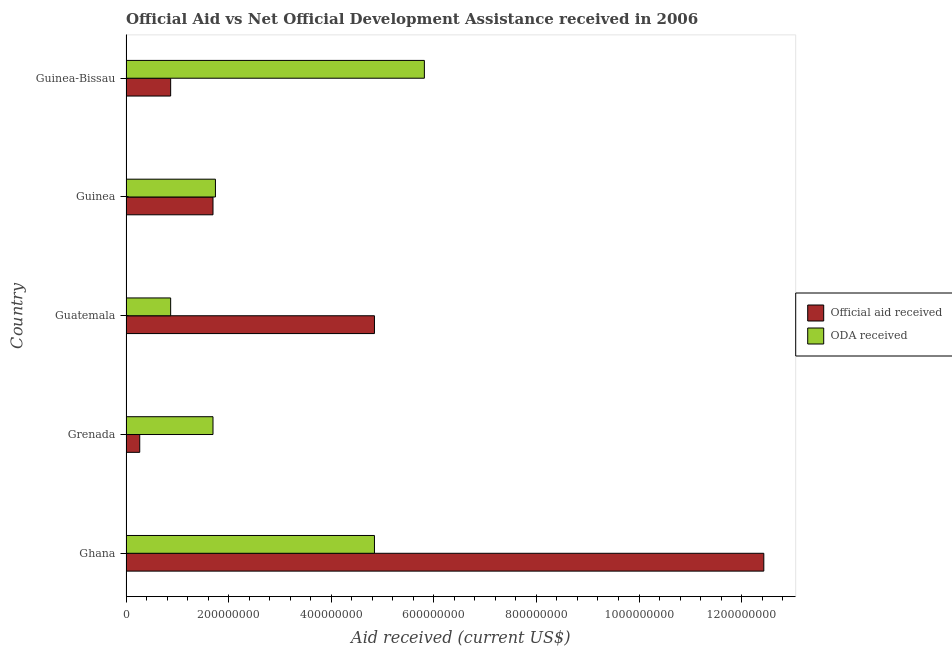Are the number of bars on each tick of the Y-axis equal?
Keep it short and to the point. Yes. How many bars are there on the 2nd tick from the top?
Offer a very short reply. 2. How many bars are there on the 4th tick from the bottom?
Provide a succinct answer. 2. What is the label of the 1st group of bars from the top?
Keep it short and to the point. Guinea-Bissau. What is the oda received in Guinea-Bissau?
Provide a succinct answer. 5.82e+08. Across all countries, what is the maximum official aid received?
Your answer should be very brief. 1.24e+09. Across all countries, what is the minimum official aid received?
Your answer should be very brief. 2.67e+07. In which country was the oda received maximum?
Your answer should be very brief. Guinea-Bissau. In which country was the official aid received minimum?
Provide a short and direct response. Grenada. What is the total oda received in the graph?
Provide a succinct answer. 1.50e+09. What is the difference between the oda received in Ghana and that in Guinea-Bissau?
Make the answer very short. -9.73e+07. What is the average oda received per country?
Your answer should be very brief. 2.99e+08. What is the difference between the oda received and official aid received in Grenada?
Your answer should be compact. 1.43e+08. Is the official aid received in Ghana less than that in Guatemala?
Provide a succinct answer. No. Is the difference between the official aid received in Grenada and Guinea greater than the difference between the oda received in Grenada and Guinea?
Your answer should be very brief. No. What is the difference between the highest and the second highest official aid received?
Offer a terse response. 7.59e+08. What is the difference between the highest and the lowest oda received?
Ensure brevity in your answer.  4.95e+08. Is the sum of the official aid received in Guatemala and Guinea greater than the maximum oda received across all countries?
Keep it short and to the point. Yes. What does the 1st bar from the top in Ghana represents?
Provide a short and direct response. ODA received. What does the 2nd bar from the bottom in Grenada represents?
Provide a succinct answer. ODA received. Are the values on the major ticks of X-axis written in scientific E-notation?
Offer a terse response. No. How many legend labels are there?
Make the answer very short. 2. What is the title of the graph?
Offer a very short reply. Official Aid vs Net Official Development Assistance received in 2006 . What is the label or title of the X-axis?
Provide a succinct answer. Aid received (current US$). What is the label or title of the Y-axis?
Offer a very short reply. Country. What is the Aid received (current US$) in Official aid received in Ghana?
Make the answer very short. 1.24e+09. What is the Aid received (current US$) of ODA received in Ghana?
Provide a succinct answer. 4.84e+08. What is the Aid received (current US$) in Official aid received in Grenada?
Give a very brief answer. 2.67e+07. What is the Aid received (current US$) of ODA received in Grenada?
Offer a very short reply. 1.70e+08. What is the Aid received (current US$) of Official aid received in Guatemala?
Make the answer very short. 4.84e+08. What is the Aid received (current US$) of ODA received in Guatemala?
Keep it short and to the point. 8.70e+07. What is the Aid received (current US$) in Official aid received in Guinea?
Your response must be concise. 1.70e+08. What is the Aid received (current US$) of ODA received in Guinea?
Your answer should be very brief. 1.74e+08. What is the Aid received (current US$) in Official aid received in Guinea-Bissau?
Give a very brief answer. 8.70e+07. What is the Aid received (current US$) in ODA received in Guinea-Bissau?
Your answer should be compact. 5.82e+08. Across all countries, what is the maximum Aid received (current US$) of Official aid received?
Keep it short and to the point. 1.24e+09. Across all countries, what is the maximum Aid received (current US$) of ODA received?
Offer a terse response. 5.82e+08. Across all countries, what is the minimum Aid received (current US$) in Official aid received?
Provide a succinct answer. 2.67e+07. Across all countries, what is the minimum Aid received (current US$) of ODA received?
Your answer should be very brief. 8.70e+07. What is the total Aid received (current US$) of Official aid received in the graph?
Ensure brevity in your answer.  2.01e+09. What is the total Aid received (current US$) in ODA received in the graph?
Make the answer very short. 1.50e+09. What is the difference between the Aid received (current US$) of Official aid received in Ghana and that in Grenada?
Your response must be concise. 1.22e+09. What is the difference between the Aid received (current US$) in ODA received in Ghana and that in Grenada?
Your answer should be very brief. 3.15e+08. What is the difference between the Aid received (current US$) in Official aid received in Ghana and that in Guatemala?
Offer a terse response. 7.59e+08. What is the difference between the Aid received (current US$) in ODA received in Ghana and that in Guatemala?
Ensure brevity in your answer.  3.97e+08. What is the difference between the Aid received (current US$) of Official aid received in Ghana and that in Guinea?
Ensure brevity in your answer.  1.07e+09. What is the difference between the Aid received (current US$) of ODA received in Ghana and that in Guinea?
Your response must be concise. 3.10e+08. What is the difference between the Aid received (current US$) of Official aid received in Ghana and that in Guinea-Bissau?
Offer a very short reply. 1.16e+09. What is the difference between the Aid received (current US$) in ODA received in Ghana and that in Guinea-Bissau?
Keep it short and to the point. -9.73e+07. What is the difference between the Aid received (current US$) of Official aid received in Grenada and that in Guatemala?
Give a very brief answer. -4.58e+08. What is the difference between the Aid received (current US$) of ODA received in Grenada and that in Guatemala?
Ensure brevity in your answer.  8.25e+07. What is the difference between the Aid received (current US$) of Official aid received in Grenada and that in Guinea?
Your answer should be very brief. -1.43e+08. What is the difference between the Aid received (current US$) of ODA received in Grenada and that in Guinea?
Ensure brevity in your answer.  -4.76e+06. What is the difference between the Aid received (current US$) in Official aid received in Grenada and that in Guinea-Bissau?
Your response must be concise. -6.03e+07. What is the difference between the Aid received (current US$) of ODA received in Grenada and that in Guinea-Bissau?
Your answer should be compact. -4.12e+08. What is the difference between the Aid received (current US$) in Official aid received in Guatemala and that in Guinea?
Your response must be concise. 3.15e+08. What is the difference between the Aid received (current US$) of ODA received in Guatemala and that in Guinea?
Give a very brief answer. -8.73e+07. What is the difference between the Aid received (current US$) of Official aid received in Guatemala and that in Guinea-Bissau?
Keep it short and to the point. 3.97e+08. What is the difference between the Aid received (current US$) in ODA received in Guatemala and that in Guinea-Bissau?
Offer a terse response. -4.95e+08. What is the difference between the Aid received (current US$) of Official aid received in Guinea and that in Guinea-Bissau?
Your answer should be very brief. 8.25e+07. What is the difference between the Aid received (current US$) of ODA received in Guinea and that in Guinea-Bissau?
Your answer should be very brief. -4.07e+08. What is the difference between the Aid received (current US$) in Official aid received in Ghana and the Aid received (current US$) in ODA received in Grenada?
Your answer should be compact. 1.07e+09. What is the difference between the Aid received (current US$) of Official aid received in Ghana and the Aid received (current US$) of ODA received in Guatemala?
Provide a short and direct response. 1.16e+09. What is the difference between the Aid received (current US$) in Official aid received in Ghana and the Aid received (current US$) in ODA received in Guinea?
Offer a very short reply. 1.07e+09. What is the difference between the Aid received (current US$) in Official aid received in Ghana and the Aid received (current US$) in ODA received in Guinea-Bissau?
Your answer should be compact. 6.62e+08. What is the difference between the Aid received (current US$) of Official aid received in Grenada and the Aid received (current US$) of ODA received in Guatemala?
Your response must be concise. -6.03e+07. What is the difference between the Aid received (current US$) in Official aid received in Grenada and the Aid received (current US$) in ODA received in Guinea?
Provide a short and direct response. -1.48e+08. What is the difference between the Aid received (current US$) in Official aid received in Grenada and the Aid received (current US$) in ODA received in Guinea-Bissau?
Ensure brevity in your answer.  -5.55e+08. What is the difference between the Aid received (current US$) in Official aid received in Guatemala and the Aid received (current US$) in ODA received in Guinea?
Your answer should be compact. 3.10e+08. What is the difference between the Aid received (current US$) in Official aid received in Guatemala and the Aid received (current US$) in ODA received in Guinea-Bissau?
Your answer should be compact. -9.73e+07. What is the difference between the Aid received (current US$) in Official aid received in Guinea and the Aid received (current US$) in ODA received in Guinea-Bissau?
Ensure brevity in your answer.  -4.12e+08. What is the average Aid received (current US$) in Official aid received per country?
Make the answer very short. 4.02e+08. What is the average Aid received (current US$) of ODA received per country?
Keep it short and to the point. 2.99e+08. What is the difference between the Aid received (current US$) in Official aid received and Aid received (current US$) in ODA received in Ghana?
Give a very brief answer. 7.59e+08. What is the difference between the Aid received (current US$) of Official aid received and Aid received (current US$) of ODA received in Grenada?
Offer a very short reply. -1.43e+08. What is the difference between the Aid received (current US$) in Official aid received and Aid received (current US$) in ODA received in Guatemala?
Your answer should be very brief. 3.97e+08. What is the difference between the Aid received (current US$) in Official aid received and Aid received (current US$) in ODA received in Guinea?
Ensure brevity in your answer.  -4.76e+06. What is the difference between the Aid received (current US$) of Official aid received and Aid received (current US$) of ODA received in Guinea-Bissau?
Keep it short and to the point. -4.95e+08. What is the ratio of the Aid received (current US$) of Official aid received in Ghana to that in Grenada?
Offer a very short reply. 46.49. What is the ratio of the Aid received (current US$) in ODA received in Ghana to that in Grenada?
Your response must be concise. 2.86. What is the ratio of the Aid received (current US$) of Official aid received in Ghana to that in Guatemala?
Provide a succinct answer. 2.57. What is the ratio of the Aid received (current US$) in ODA received in Ghana to that in Guatemala?
Ensure brevity in your answer.  5.57. What is the ratio of the Aid received (current US$) in Official aid received in Ghana to that in Guinea?
Provide a succinct answer. 7.33. What is the ratio of the Aid received (current US$) in ODA received in Ghana to that in Guinea?
Provide a succinct answer. 2.78. What is the ratio of the Aid received (current US$) in Official aid received in Ghana to that in Guinea-Bissau?
Give a very brief answer. 14.29. What is the ratio of the Aid received (current US$) of ODA received in Ghana to that in Guinea-Bissau?
Provide a succinct answer. 0.83. What is the ratio of the Aid received (current US$) of Official aid received in Grenada to that in Guatemala?
Ensure brevity in your answer.  0.06. What is the ratio of the Aid received (current US$) of ODA received in Grenada to that in Guatemala?
Provide a short and direct response. 1.95. What is the ratio of the Aid received (current US$) of Official aid received in Grenada to that in Guinea?
Your answer should be very brief. 0.16. What is the ratio of the Aid received (current US$) of ODA received in Grenada to that in Guinea?
Your response must be concise. 0.97. What is the ratio of the Aid received (current US$) of Official aid received in Grenada to that in Guinea-Bissau?
Make the answer very short. 0.31. What is the ratio of the Aid received (current US$) of ODA received in Grenada to that in Guinea-Bissau?
Make the answer very short. 0.29. What is the ratio of the Aid received (current US$) of Official aid received in Guatemala to that in Guinea?
Make the answer very short. 2.86. What is the ratio of the Aid received (current US$) in ODA received in Guatemala to that in Guinea?
Provide a succinct answer. 0.5. What is the ratio of the Aid received (current US$) of Official aid received in Guatemala to that in Guinea-Bissau?
Provide a short and direct response. 5.57. What is the ratio of the Aid received (current US$) in ODA received in Guatemala to that in Guinea-Bissau?
Your answer should be compact. 0.15. What is the ratio of the Aid received (current US$) in Official aid received in Guinea to that in Guinea-Bissau?
Ensure brevity in your answer.  1.95. What is the ratio of the Aid received (current US$) in ODA received in Guinea to that in Guinea-Bissau?
Keep it short and to the point. 0.3. What is the difference between the highest and the second highest Aid received (current US$) of Official aid received?
Provide a succinct answer. 7.59e+08. What is the difference between the highest and the second highest Aid received (current US$) of ODA received?
Your response must be concise. 9.73e+07. What is the difference between the highest and the lowest Aid received (current US$) in Official aid received?
Ensure brevity in your answer.  1.22e+09. What is the difference between the highest and the lowest Aid received (current US$) of ODA received?
Provide a succinct answer. 4.95e+08. 